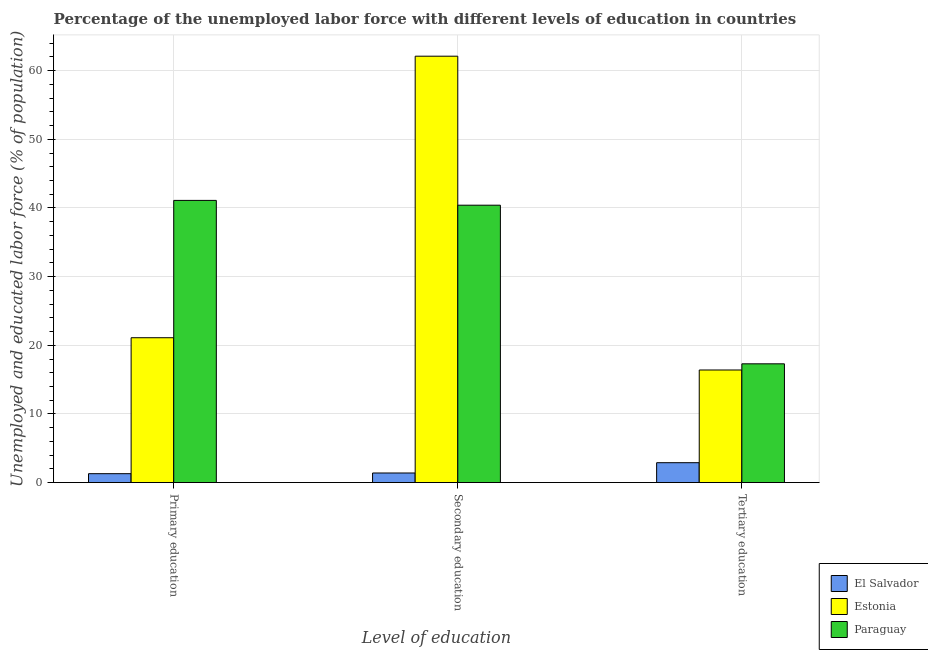How many different coloured bars are there?
Offer a terse response. 3. Are the number of bars on each tick of the X-axis equal?
Your answer should be very brief. Yes. What is the percentage of labor force who received primary education in Estonia?
Provide a short and direct response. 21.1. Across all countries, what is the maximum percentage of labor force who received secondary education?
Give a very brief answer. 62.1. Across all countries, what is the minimum percentage of labor force who received secondary education?
Ensure brevity in your answer.  1.4. In which country was the percentage of labor force who received secondary education maximum?
Provide a short and direct response. Estonia. In which country was the percentage of labor force who received secondary education minimum?
Keep it short and to the point. El Salvador. What is the total percentage of labor force who received primary education in the graph?
Provide a succinct answer. 63.5. What is the difference between the percentage of labor force who received primary education in Estonia and that in El Salvador?
Offer a terse response. 19.8. What is the difference between the percentage of labor force who received primary education in El Salvador and the percentage of labor force who received secondary education in Paraguay?
Provide a succinct answer. -39.1. What is the average percentage of labor force who received tertiary education per country?
Your answer should be very brief. 12.2. What is the difference between the percentage of labor force who received secondary education and percentage of labor force who received tertiary education in Estonia?
Your answer should be very brief. 45.7. In how many countries, is the percentage of labor force who received secondary education greater than 56 %?
Give a very brief answer. 1. What is the ratio of the percentage of labor force who received primary education in Paraguay to that in El Salvador?
Your answer should be compact. 31.62. Is the percentage of labor force who received tertiary education in El Salvador less than that in Paraguay?
Provide a succinct answer. Yes. Is the difference between the percentage of labor force who received primary education in El Salvador and Estonia greater than the difference between the percentage of labor force who received tertiary education in El Salvador and Estonia?
Give a very brief answer. No. What is the difference between the highest and the second highest percentage of labor force who received tertiary education?
Your answer should be very brief. 0.9. What is the difference between the highest and the lowest percentage of labor force who received tertiary education?
Your answer should be very brief. 14.4. Is the sum of the percentage of labor force who received primary education in Estonia and Paraguay greater than the maximum percentage of labor force who received tertiary education across all countries?
Offer a terse response. Yes. What does the 1st bar from the left in Tertiary education represents?
Offer a very short reply. El Salvador. What does the 3rd bar from the right in Secondary education represents?
Your answer should be compact. El Salvador. How many bars are there?
Ensure brevity in your answer.  9. Are all the bars in the graph horizontal?
Your response must be concise. No. How many countries are there in the graph?
Keep it short and to the point. 3. What is the difference between two consecutive major ticks on the Y-axis?
Offer a very short reply. 10. Does the graph contain grids?
Make the answer very short. Yes. Where does the legend appear in the graph?
Offer a very short reply. Bottom right. How are the legend labels stacked?
Provide a succinct answer. Vertical. What is the title of the graph?
Provide a short and direct response. Percentage of the unemployed labor force with different levels of education in countries. Does "Spain" appear as one of the legend labels in the graph?
Offer a terse response. No. What is the label or title of the X-axis?
Your response must be concise. Level of education. What is the label or title of the Y-axis?
Make the answer very short. Unemployed and educated labor force (% of population). What is the Unemployed and educated labor force (% of population) of El Salvador in Primary education?
Your response must be concise. 1.3. What is the Unemployed and educated labor force (% of population) in Estonia in Primary education?
Offer a very short reply. 21.1. What is the Unemployed and educated labor force (% of population) in Paraguay in Primary education?
Offer a terse response. 41.1. What is the Unemployed and educated labor force (% of population) in El Salvador in Secondary education?
Ensure brevity in your answer.  1.4. What is the Unemployed and educated labor force (% of population) of Estonia in Secondary education?
Keep it short and to the point. 62.1. What is the Unemployed and educated labor force (% of population) in Paraguay in Secondary education?
Offer a very short reply. 40.4. What is the Unemployed and educated labor force (% of population) in El Salvador in Tertiary education?
Your answer should be compact. 2.9. What is the Unemployed and educated labor force (% of population) of Estonia in Tertiary education?
Keep it short and to the point. 16.4. What is the Unemployed and educated labor force (% of population) of Paraguay in Tertiary education?
Give a very brief answer. 17.3. Across all Level of education, what is the maximum Unemployed and educated labor force (% of population) in El Salvador?
Keep it short and to the point. 2.9. Across all Level of education, what is the maximum Unemployed and educated labor force (% of population) in Estonia?
Ensure brevity in your answer.  62.1. Across all Level of education, what is the maximum Unemployed and educated labor force (% of population) in Paraguay?
Give a very brief answer. 41.1. Across all Level of education, what is the minimum Unemployed and educated labor force (% of population) of El Salvador?
Your response must be concise. 1.3. Across all Level of education, what is the minimum Unemployed and educated labor force (% of population) of Estonia?
Provide a short and direct response. 16.4. Across all Level of education, what is the minimum Unemployed and educated labor force (% of population) of Paraguay?
Offer a terse response. 17.3. What is the total Unemployed and educated labor force (% of population) of Estonia in the graph?
Make the answer very short. 99.6. What is the total Unemployed and educated labor force (% of population) in Paraguay in the graph?
Keep it short and to the point. 98.8. What is the difference between the Unemployed and educated labor force (% of population) in Estonia in Primary education and that in Secondary education?
Ensure brevity in your answer.  -41. What is the difference between the Unemployed and educated labor force (% of population) of Paraguay in Primary education and that in Secondary education?
Your response must be concise. 0.7. What is the difference between the Unemployed and educated labor force (% of population) in El Salvador in Primary education and that in Tertiary education?
Offer a terse response. -1.6. What is the difference between the Unemployed and educated labor force (% of population) of Paraguay in Primary education and that in Tertiary education?
Offer a terse response. 23.8. What is the difference between the Unemployed and educated labor force (% of population) of Estonia in Secondary education and that in Tertiary education?
Give a very brief answer. 45.7. What is the difference between the Unemployed and educated labor force (% of population) of Paraguay in Secondary education and that in Tertiary education?
Ensure brevity in your answer.  23.1. What is the difference between the Unemployed and educated labor force (% of population) of El Salvador in Primary education and the Unemployed and educated labor force (% of population) of Estonia in Secondary education?
Make the answer very short. -60.8. What is the difference between the Unemployed and educated labor force (% of population) in El Salvador in Primary education and the Unemployed and educated labor force (% of population) in Paraguay in Secondary education?
Your answer should be very brief. -39.1. What is the difference between the Unemployed and educated labor force (% of population) of Estonia in Primary education and the Unemployed and educated labor force (% of population) of Paraguay in Secondary education?
Provide a short and direct response. -19.3. What is the difference between the Unemployed and educated labor force (% of population) of El Salvador in Primary education and the Unemployed and educated labor force (% of population) of Estonia in Tertiary education?
Your answer should be very brief. -15.1. What is the difference between the Unemployed and educated labor force (% of population) of El Salvador in Primary education and the Unemployed and educated labor force (% of population) of Paraguay in Tertiary education?
Your answer should be compact. -16. What is the difference between the Unemployed and educated labor force (% of population) of El Salvador in Secondary education and the Unemployed and educated labor force (% of population) of Estonia in Tertiary education?
Provide a short and direct response. -15. What is the difference between the Unemployed and educated labor force (% of population) of El Salvador in Secondary education and the Unemployed and educated labor force (% of population) of Paraguay in Tertiary education?
Your answer should be compact. -15.9. What is the difference between the Unemployed and educated labor force (% of population) of Estonia in Secondary education and the Unemployed and educated labor force (% of population) of Paraguay in Tertiary education?
Provide a short and direct response. 44.8. What is the average Unemployed and educated labor force (% of population) in El Salvador per Level of education?
Your response must be concise. 1.87. What is the average Unemployed and educated labor force (% of population) of Estonia per Level of education?
Keep it short and to the point. 33.2. What is the average Unemployed and educated labor force (% of population) of Paraguay per Level of education?
Your answer should be very brief. 32.93. What is the difference between the Unemployed and educated labor force (% of population) of El Salvador and Unemployed and educated labor force (% of population) of Estonia in Primary education?
Your answer should be compact. -19.8. What is the difference between the Unemployed and educated labor force (% of population) in El Salvador and Unemployed and educated labor force (% of population) in Paraguay in Primary education?
Give a very brief answer. -39.8. What is the difference between the Unemployed and educated labor force (% of population) of El Salvador and Unemployed and educated labor force (% of population) of Estonia in Secondary education?
Provide a succinct answer. -60.7. What is the difference between the Unemployed and educated labor force (% of population) in El Salvador and Unemployed and educated labor force (% of population) in Paraguay in Secondary education?
Give a very brief answer. -39. What is the difference between the Unemployed and educated labor force (% of population) in Estonia and Unemployed and educated labor force (% of population) in Paraguay in Secondary education?
Keep it short and to the point. 21.7. What is the difference between the Unemployed and educated labor force (% of population) of El Salvador and Unemployed and educated labor force (% of population) of Estonia in Tertiary education?
Make the answer very short. -13.5. What is the difference between the Unemployed and educated labor force (% of population) of El Salvador and Unemployed and educated labor force (% of population) of Paraguay in Tertiary education?
Keep it short and to the point. -14.4. What is the ratio of the Unemployed and educated labor force (% of population) in Estonia in Primary education to that in Secondary education?
Give a very brief answer. 0.34. What is the ratio of the Unemployed and educated labor force (% of population) of Paraguay in Primary education to that in Secondary education?
Offer a very short reply. 1.02. What is the ratio of the Unemployed and educated labor force (% of population) in El Salvador in Primary education to that in Tertiary education?
Your answer should be very brief. 0.45. What is the ratio of the Unemployed and educated labor force (% of population) in Estonia in Primary education to that in Tertiary education?
Ensure brevity in your answer.  1.29. What is the ratio of the Unemployed and educated labor force (% of population) of Paraguay in Primary education to that in Tertiary education?
Provide a succinct answer. 2.38. What is the ratio of the Unemployed and educated labor force (% of population) of El Salvador in Secondary education to that in Tertiary education?
Your response must be concise. 0.48. What is the ratio of the Unemployed and educated labor force (% of population) of Estonia in Secondary education to that in Tertiary education?
Your answer should be very brief. 3.79. What is the ratio of the Unemployed and educated labor force (% of population) of Paraguay in Secondary education to that in Tertiary education?
Provide a succinct answer. 2.34. What is the difference between the highest and the second highest Unemployed and educated labor force (% of population) in El Salvador?
Your answer should be compact. 1.5. What is the difference between the highest and the second highest Unemployed and educated labor force (% of population) in Estonia?
Your response must be concise. 41. What is the difference between the highest and the lowest Unemployed and educated labor force (% of population) in El Salvador?
Give a very brief answer. 1.6. What is the difference between the highest and the lowest Unemployed and educated labor force (% of population) of Estonia?
Your answer should be very brief. 45.7. What is the difference between the highest and the lowest Unemployed and educated labor force (% of population) of Paraguay?
Offer a very short reply. 23.8. 